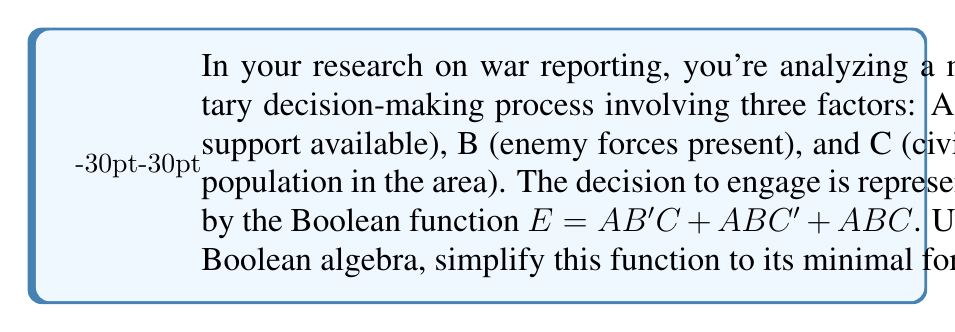Provide a solution to this math problem. Let's simplify the Boolean function $E = AB'C + ABC' + ABC$ step by step:

1) First, we can factor out AB from the last two terms:
   $E = AB'C + AB(C' + C)$

2) Recall that $C' + C = 1$ (complement law):
   $E = AB'C + AB(1)$

3) Simplify:
   $E = AB'C + AB$

4) Now, we can factor out A:
   $E = A(B'C + B)$

5) Distribute B over the parentheses:
   $E = A(B'C + B)$
   $E = AB'C + AB$

This is our simplified form. We can verify that this is equivalent to our original function:

$AB'C$ covers the first term of the original function.
$AB$ covers both $ABC'$ and $ABC$ from the original function.

Therefore, $E = AB'C + AB$ is the minimal form of the original function.
Answer: $E = AB'C + AB$ 